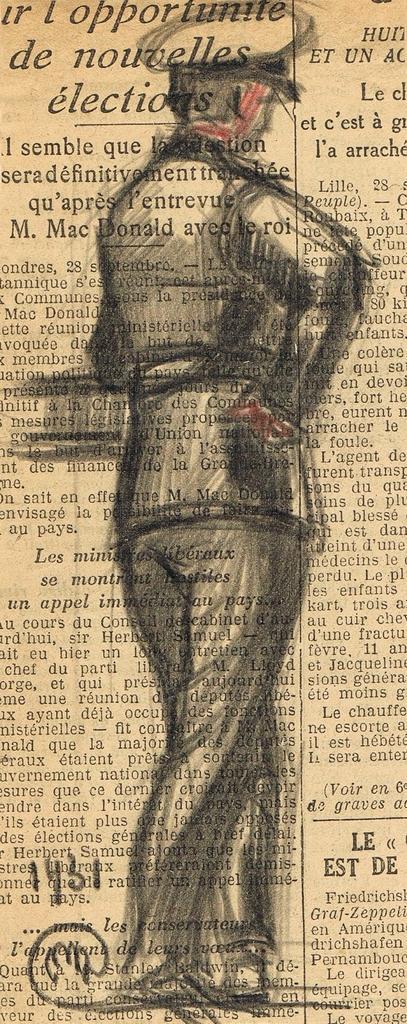In one or two sentences, can you explain what this image depicts? In this image we can see a newspaper on which we can see some printed text and an art of a person wearing a uniform and a cap is made on it. 